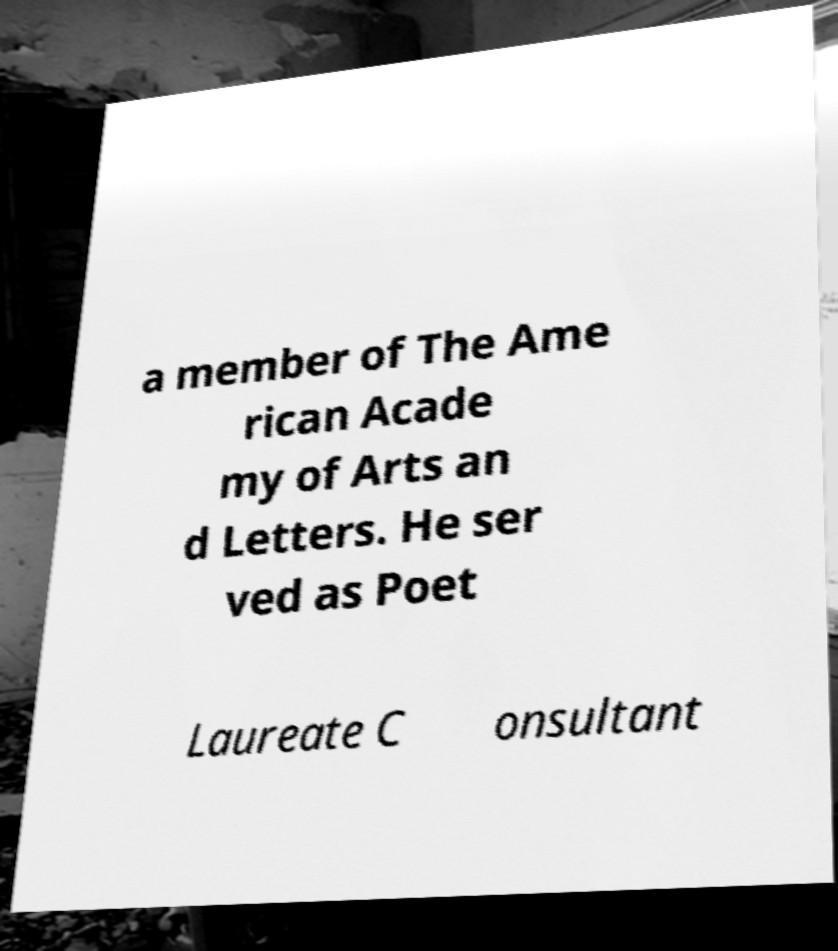Please identify and transcribe the text found in this image. a member of The Ame rican Acade my of Arts an d Letters. He ser ved as Poet Laureate C onsultant 